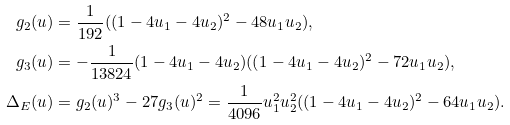Convert formula to latex. <formula><loc_0><loc_0><loc_500><loc_500>g _ { 2 } ( u ) & = \frac { 1 } { 1 9 2 } ( ( 1 - 4 u _ { 1 } - 4 u _ { 2 } ) ^ { 2 } - 4 8 u _ { 1 } u _ { 2 } ) , \\ g _ { 3 } ( u ) & = - \frac { 1 } { 1 3 8 2 4 } ( 1 - 4 u _ { 1 } - 4 u _ { 2 } ) ( ( 1 - 4 u _ { 1 } - 4 u _ { 2 } ) ^ { 2 } - 7 2 u _ { 1 } u _ { 2 } ) , \\ \Delta _ { E } ( u ) & = g _ { 2 } ( u ) ^ { 3 } - 2 7 g _ { 3 } ( u ) ^ { 2 } = \frac { 1 } { 4 0 9 6 } u _ { 1 } ^ { 2 } u _ { 2 } ^ { 2 } ( ( 1 - 4 u _ { 1 } - 4 u _ { 2 } ) ^ { 2 } - 6 4 u _ { 1 } u _ { 2 } ) .</formula> 